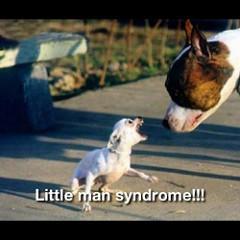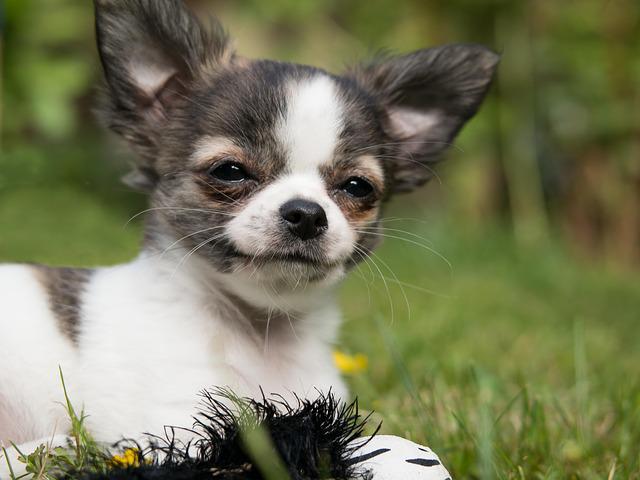The first image is the image on the left, the second image is the image on the right. Analyze the images presented: Is the assertion "A chihuahua with its body turned toward the camera is baring its fangs." valid? Answer yes or no. No. The first image is the image on the left, the second image is the image on the right. Assess this claim about the two images: "The right image contains no more than one dog.". Correct or not? Answer yes or no. Yes. 